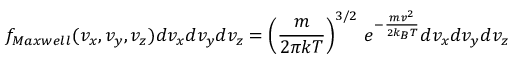<formula> <loc_0><loc_0><loc_500><loc_500>f _ { M a x w e l l } ( v _ { x } , v _ { y } , v _ { z } ) d v _ { x } d v _ { y } d v _ { z } = \left ( { \frac { m } { 2 \pi k T } } \right ) ^ { 3 / 2 } \, e ^ { - { \frac { m v ^ { 2 } } { 2 k _ { B } T } } } d v _ { x } d v _ { y } d v _ { z }</formula> 